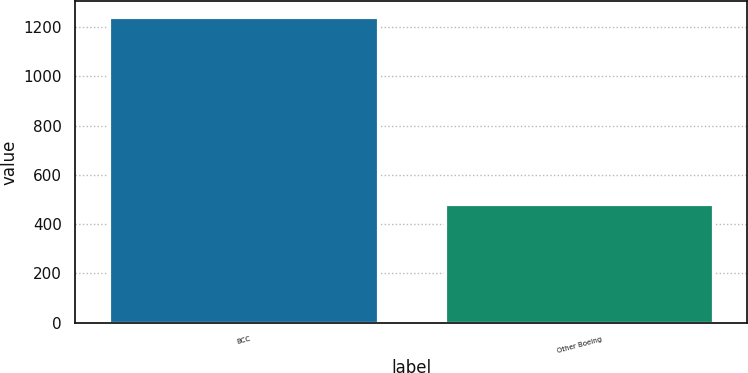Convert chart. <chart><loc_0><loc_0><loc_500><loc_500><bar_chart><fcel>BCC<fcel>Other Boeing<nl><fcel>1242<fcel>483<nl></chart> 